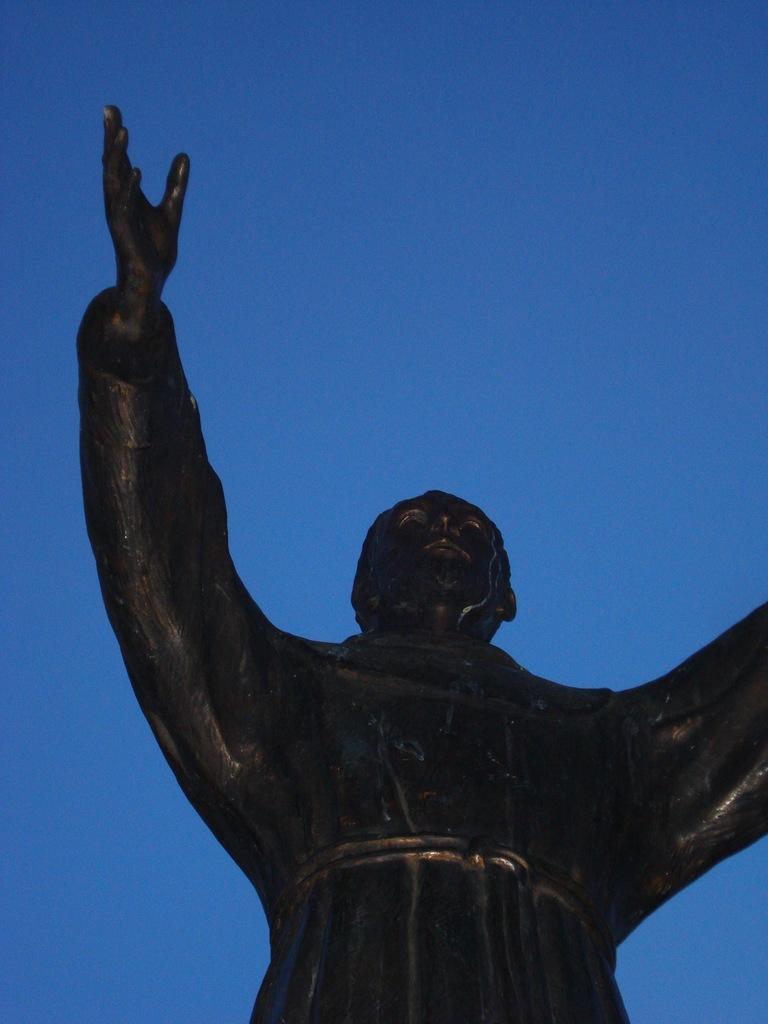Can you describe this image briefly? In this image we can see a statue and sky in the background. 